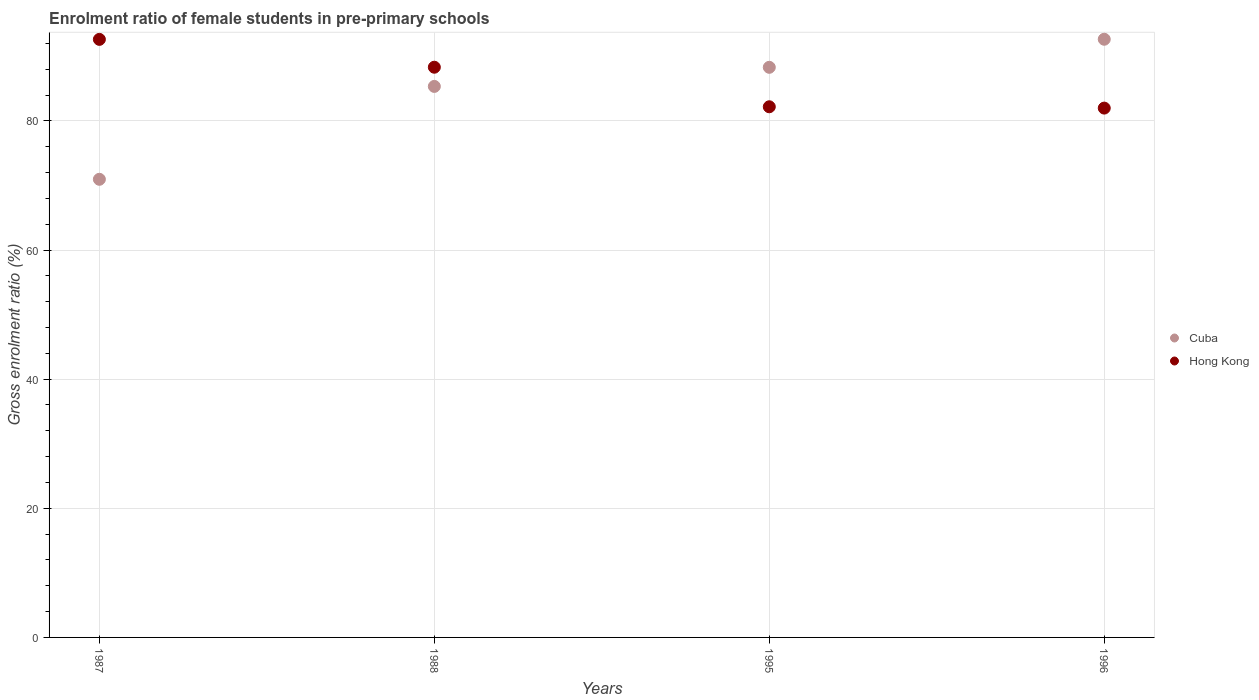Is the number of dotlines equal to the number of legend labels?
Provide a short and direct response. Yes. What is the enrolment ratio of female students in pre-primary schools in Hong Kong in 1995?
Give a very brief answer. 82.19. Across all years, what is the maximum enrolment ratio of female students in pre-primary schools in Hong Kong?
Provide a short and direct response. 92.63. Across all years, what is the minimum enrolment ratio of female students in pre-primary schools in Hong Kong?
Ensure brevity in your answer.  81.98. In which year was the enrolment ratio of female students in pre-primary schools in Hong Kong minimum?
Offer a very short reply. 1996. What is the total enrolment ratio of female students in pre-primary schools in Cuba in the graph?
Your response must be concise. 337.24. What is the difference between the enrolment ratio of female students in pre-primary schools in Hong Kong in 1995 and that in 1996?
Ensure brevity in your answer.  0.2. What is the difference between the enrolment ratio of female students in pre-primary schools in Cuba in 1995 and the enrolment ratio of female students in pre-primary schools in Hong Kong in 1987?
Your answer should be very brief. -4.33. What is the average enrolment ratio of female students in pre-primary schools in Cuba per year?
Keep it short and to the point. 84.31. In the year 1987, what is the difference between the enrolment ratio of female students in pre-primary schools in Cuba and enrolment ratio of female students in pre-primary schools in Hong Kong?
Make the answer very short. -21.67. In how many years, is the enrolment ratio of female students in pre-primary schools in Hong Kong greater than 52 %?
Give a very brief answer. 4. What is the ratio of the enrolment ratio of female students in pre-primary schools in Hong Kong in 1987 to that in 1988?
Offer a very short reply. 1.05. Is the difference between the enrolment ratio of female students in pre-primary schools in Cuba in 1988 and 1996 greater than the difference between the enrolment ratio of female students in pre-primary schools in Hong Kong in 1988 and 1996?
Your response must be concise. No. What is the difference between the highest and the second highest enrolment ratio of female students in pre-primary schools in Cuba?
Make the answer very short. 4.35. What is the difference between the highest and the lowest enrolment ratio of female students in pre-primary schools in Hong Kong?
Your response must be concise. 10.64. In how many years, is the enrolment ratio of female students in pre-primary schools in Hong Kong greater than the average enrolment ratio of female students in pre-primary schools in Hong Kong taken over all years?
Your answer should be very brief. 2. Is the sum of the enrolment ratio of female students in pre-primary schools in Cuba in 1995 and 1996 greater than the maximum enrolment ratio of female students in pre-primary schools in Hong Kong across all years?
Offer a very short reply. Yes. Is the enrolment ratio of female students in pre-primary schools in Hong Kong strictly greater than the enrolment ratio of female students in pre-primary schools in Cuba over the years?
Keep it short and to the point. No. Is the enrolment ratio of female students in pre-primary schools in Hong Kong strictly less than the enrolment ratio of female students in pre-primary schools in Cuba over the years?
Your answer should be very brief. No. How many years are there in the graph?
Your answer should be very brief. 4. Are the values on the major ticks of Y-axis written in scientific E-notation?
Provide a short and direct response. No. Does the graph contain any zero values?
Make the answer very short. No. How are the legend labels stacked?
Your answer should be very brief. Vertical. What is the title of the graph?
Ensure brevity in your answer.  Enrolment ratio of female students in pre-primary schools. Does "Dominica" appear as one of the legend labels in the graph?
Offer a terse response. No. What is the label or title of the Y-axis?
Provide a short and direct response. Gross enrolment ratio (%). What is the Gross enrolment ratio (%) of Cuba in 1987?
Provide a short and direct response. 70.95. What is the Gross enrolment ratio (%) of Hong Kong in 1987?
Your answer should be compact. 92.63. What is the Gross enrolment ratio (%) in Cuba in 1988?
Provide a succinct answer. 85.34. What is the Gross enrolment ratio (%) in Hong Kong in 1988?
Give a very brief answer. 88.31. What is the Gross enrolment ratio (%) in Cuba in 1995?
Give a very brief answer. 88.3. What is the Gross enrolment ratio (%) in Hong Kong in 1995?
Make the answer very short. 82.19. What is the Gross enrolment ratio (%) in Cuba in 1996?
Give a very brief answer. 92.64. What is the Gross enrolment ratio (%) in Hong Kong in 1996?
Offer a terse response. 81.98. Across all years, what is the maximum Gross enrolment ratio (%) of Cuba?
Provide a short and direct response. 92.64. Across all years, what is the maximum Gross enrolment ratio (%) of Hong Kong?
Make the answer very short. 92.63. Across all years, what is the minimum Gross enrolment ratio (%) of Cuba?
Your answer should be very brief. 70.95. Across all years, what is the minimum Gross enrolment ratio (%) of Hong Kong?
Provide a succinct answer. 81.98. What is the total Gross enrolment ratio (%) of Cuba in the graph?
Keep it short and to the point. 337.24. What is the total Gross enrolment ratio (%) in Hong Kong in the graph?
Give a very brief answer. 345.11. What is the difference between the Gross enrolment ratio (%) in Cuba in 1987 and that in 1988?
Provide a succinct answer. -14.39. What is the difference between the Gross enrolment ratio (%) in Hong Kong in 1987 and that in 1988?
Provide a short and direct response. 4.31. What is the difference between the Gross enrolment ratio (%) of Cuba in 1987 and that in 1995?
Your response must be concise. -17.34. What is the difference between the Gross enrolment ratio (%) in Hong Kong in 1987 and that in 1995?
Your answer should be very brief. 10.44. What is the difference between the Gross enrolment ratio (%) of Cuba in 1987 and that in 1996?
Provide a short and direct response. -21.69. What is the difference between the Gross enrolment ratio (%) in Hong Kong in 1987 and that in 1996?
Offer a very short reply. 10.64. What is the difference between the Gross enrolment ratio (%) of Cuba in 1988 and that in 1995?
Your response must be concise. -2.96. What is the difference between the Gross enrolment ratio (%) of Hong Kong in 1988 and that in 1995?
Give a very brief answer. 6.13. What is the difference between the Gross enrolment ratio (%) in Cuba in 1988 and that in 1996?
Ensure brevity in your answer.  -7.3. What is the difference between the Gross enrolment ratio (%) of Hong Kong in 1988 and that in 1996?
Make the answer very short. 6.33. What is the difference between the Gross enrolment ratio (%) of Cuba in 1995 and that in 1996?
Keep it short and to the point. -4.35. What is the difference between the Gross enrolment ratio (%) of Hong Kong in 1995 and that in 1996?
Keep it short and to the point. 0.2. What is the difference between the Gross enrolment ratio (%) in Cuba in 1987 and the Gross enrolment ratio (%) in Hong Kong in 1988?
Offer a terse response. -17.36. What is the difference between the Gross enrolment ratio (%) in Cuba in 1987 and the Gross enrolment ratio (%) in Hong Kong in 1995?
Offer a very short reply. -11.23. What is the difference between the Gross enrolment ratio (%) in Cuba in 1987 and the Gross enrolment ratio (%) in Hong Kong in 1996?
Give a very brief answer. -11.03. What is the difference between the Gross enrolment ratio (%) in Cuba in 1988 and the Gross enrolment ratio (%) in Hong Kong in 1995?
Offer a very short reply. 3.15. What is the difference between the Gross enrolment ratio (%) in Cuba in 1988 and the Gross enrolment ratio (%) in Hong Kong in 1996?
Offer a very short reply. 3.36. What is the difference between the Gross enrolment ratio (%) of Cuba in 1995 and the Gross enrolment ratio (%) of Hong Kong in 1996?
Provide a short and direct response. 6.32. What is the average Gross enrolment ratio (%) in Cuba per year?
Offer a terse response. 84.31. What is the average Gross enrolment ratio (%) in Hong Kong per year?
Offer a very short reply. 86.28. In the year 1987, what is the difference between the Gross enrolment ratio (%) in Cuba and Gross enrolment ratio (%) in Hong Kong?
Offer a very short reply. -21.67. In the year 1988, what is the difference between the Gross enrolment ratio (%) in Cuba and Gross enrolment ratio (%) in Hong Kong?
Ensure brevity in your answer.  -2.97. In the year 1995, what is the difference between the Gross enrolment ratio (%) in Cuba and Gross enrolment ratio (%) in Hong Kong?
Ensure brevity in your answer.  6.11. In the year 1996, what is the difference between the Gross enrolment ratio (%) in Cuba and Gross enrolment ratio (%) in Hong Kong?
Give a very brief answer. 10.66. What is the ratio of the Gross enrolment ratio (%) of Cuba in 1987 to that in 1988?
Offer a very short reply. 0.83. What is the ratio of the Gross enrolment ratio (%) of Hong Kong in 1987 to that in 1988?
Provide a short and direct response. 1.05. What is the ratio of the Gross enrolment ratio (%) of Cuba in 1987 to that in 1995?
Your answer should be very brief. 0.8. What is the ratio of the Gross enrolment ratio (%) of Hong Kong in 1987 to that in 1995?
Provide a succinct answer. 1.13. What is the ratio of the Gross enrolment ratio (%) in Cuba in 1987 to that in 1996?
Provide a short and direct response. 0.77. What is the ratio of the Gross enrolment ratio (%) in Hong Kong in 1987 to that in 1996?
Provide a succinct answer. 1.13. What is the ratio of the Gross enrolment ratio (%) in Cuba in 1988 to that in 1995?
Keep it short and to the point. 0.97. What is the ratio of the Gross enrolment ratio (%) in Hong Kong in 1988 to that in 1995?
Your answer should be very brief. 1.07. What is the ratio of the Gross enrolment ratio (%) in Cuba in 1988 to that in 1996?
Give a very brief answer. 0.92. What is the ratio of the Gross enrolment ratio (%) in Hong Kong in 1988 to that in 1996?
Make the answer very short. 1.08. What is the ratio of the Gross enrolment ratio (%) of Cuba in 1995 to that in 1996?
Give a very brief answer. 0.95. What is the difference between the highest and the second highest Gross enrolment ratio (%) in Cuba?
Keep it short and to the point. 4.35. What is the difference between the highest and the second highest Gross enrolment ratio (%) in Hong Kong?
Ensure brevity in your answer.  4.31. What is the difference between the highest and the lowest Gross enrolment ratio (%) in Cuba?
Offer a terse response. 21.69. What is the difference between the highest and the lowest Gross enrolment ratio (%) of Hong Kong?
Offer a terse response. 10.64. 